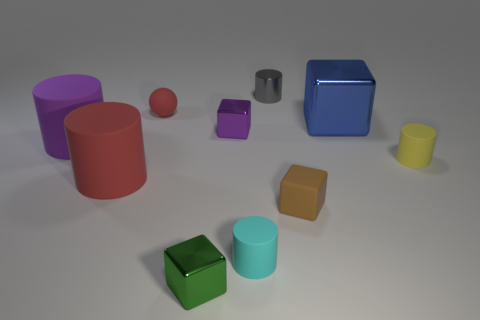Subtract all purple cylinders. How many cylinders are left? 4 Subtract all red rubber cylinders. How many cylinders are left? 4 Subtract all yellow cylinders. Subtract all purple cubes. How many cylinders are left? 4 Subtract all spheres. How many objects are left? 9 Subtract 0 red blocks. How many objects are left? 10 Subtract all tiny gray blocks. Subtract all small yellow matte objects. How many objects are left? 9 Add 7 rubber cubes. How many rubber cubes are left? 8 Add 7 small yellow rubber objects. How many small yellow rubber objects exist? 8 